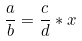Convert formula to latex. <formula><loc_0><loc_0><loc_500><loc_500>\frac { a } { b } = \frac { c } { d } * x</formula> 